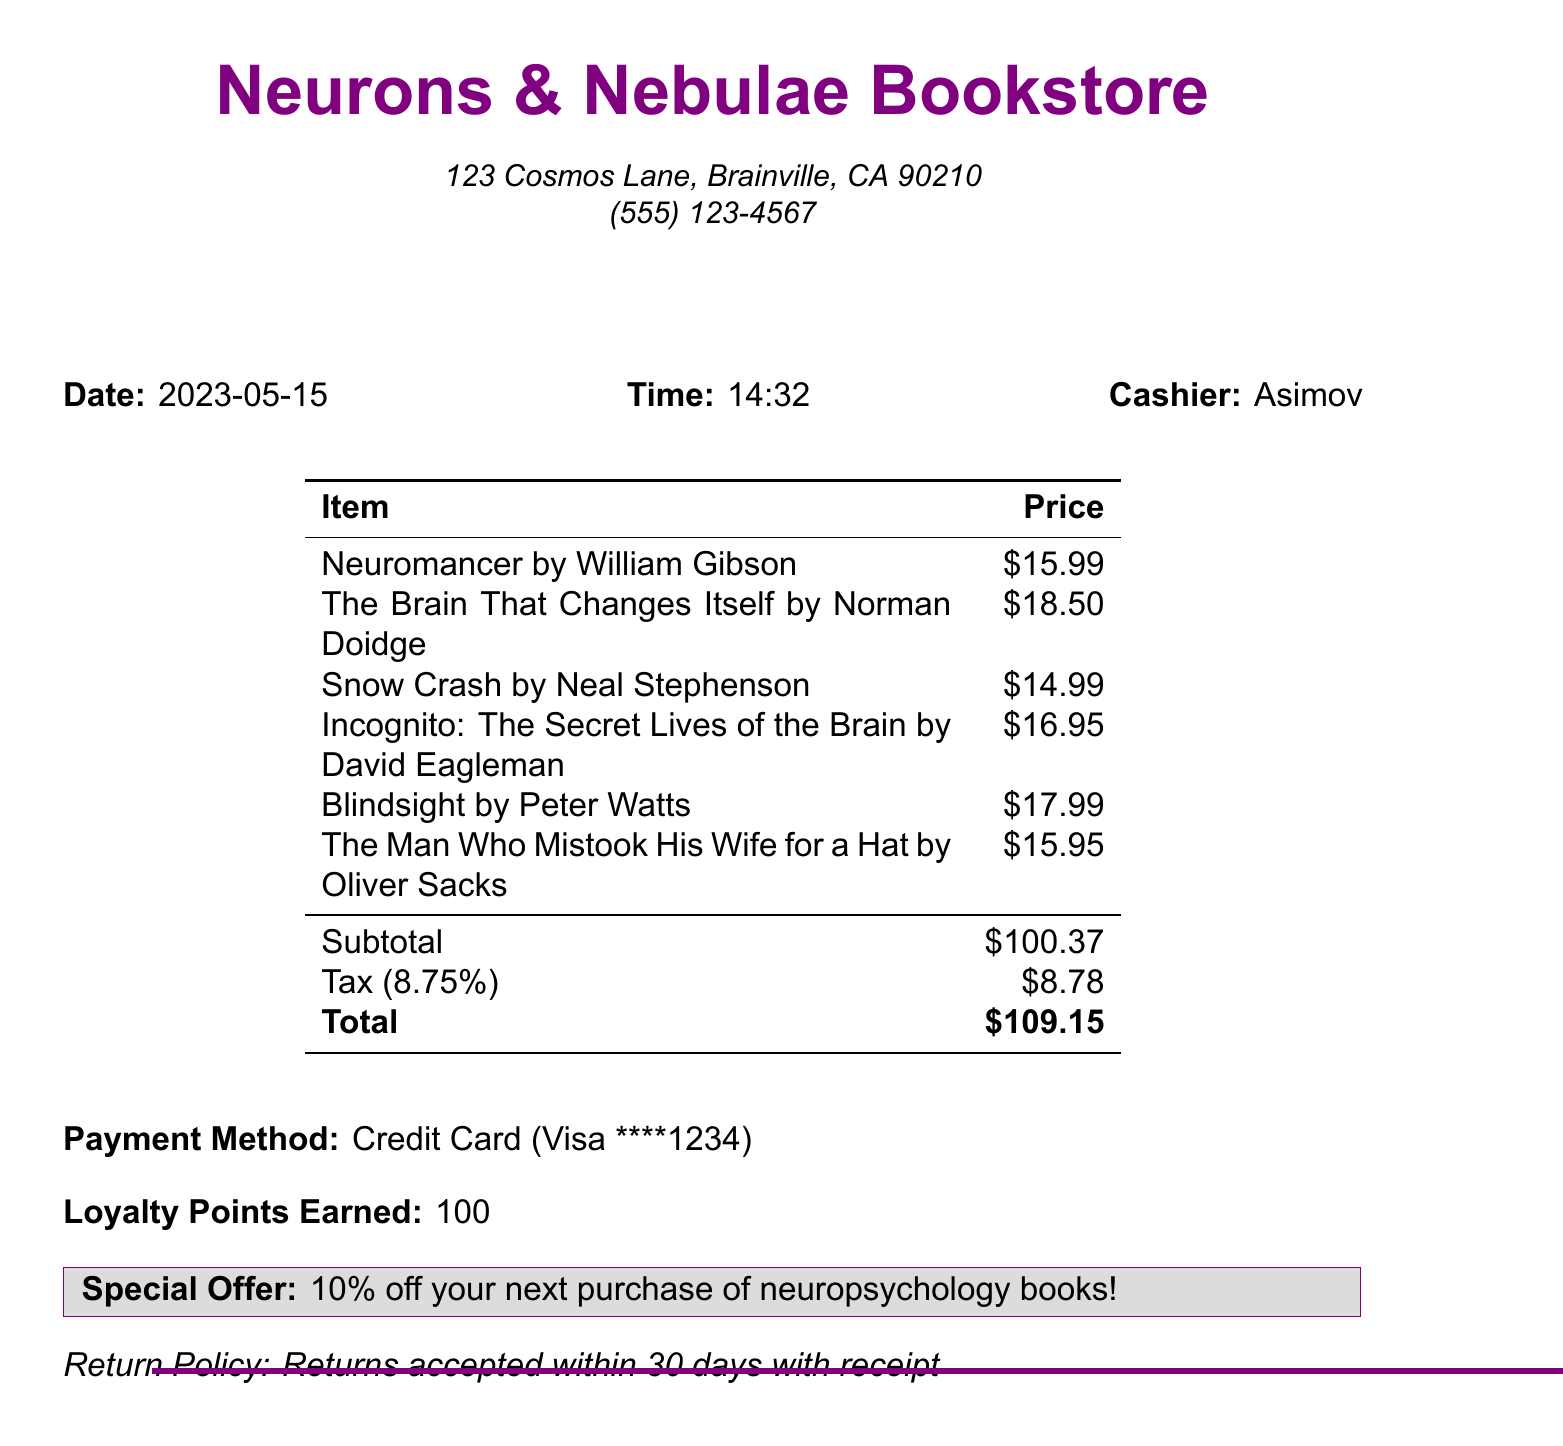What is the name of the bookstore? The document lists the name of the store as Neurons & Nebulae Bookstore.
Answer: Neurons & Nebulae Bookstore What is the total amount spent? The total amount spent is the last figure presented in the receipt, which includes tax and the subtotal.
Answer: $109.15 Who is the author of "Neuromancer"? The document specifies that William Gibson is the author of "Neuromancer".
Answer: William Gibson What is the tax amount? The tax amount is explicitly stated in the receipt as a separate line item.
Answer: $8.78 How many loyalty points were earned? The document states the number of loyalty points earned in the final section.
Answer: 100 What category does "Incognito: The Secret Lives of the Brain" belong to? The document categorizes this title under Neuroscience.
Answer: Neuroscience What payment method was used? The payment method is clearly indicated in the document stating it was a Credit Card.
Answer: Credit Card What special offer is mentioned? The document mentions that there is a special offer related to neuropsychology books.
Answer: 10% off your next purchase of neuropsychology books! How many items were purchased in total? The sum of all items listed in the receipt is 6, as per the itemized list.
Answer: 6 